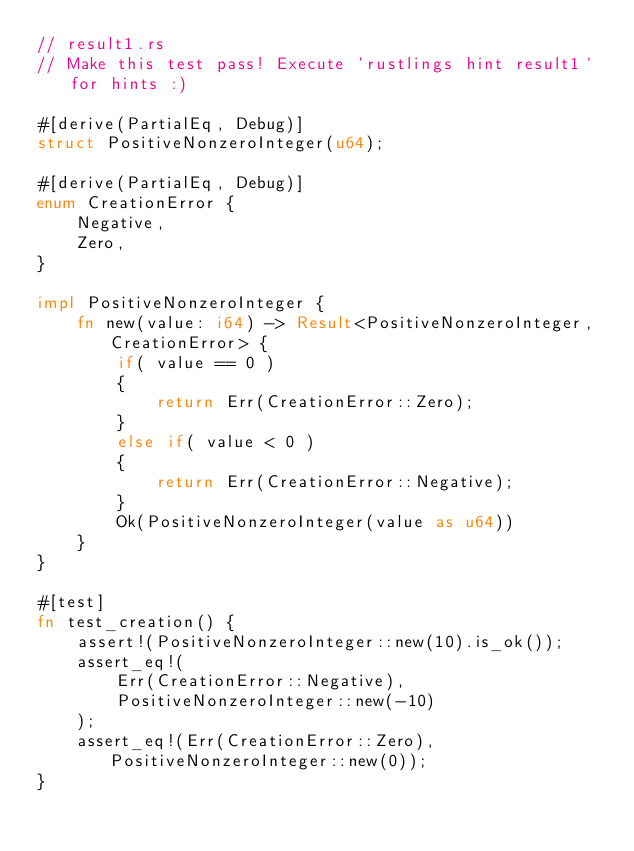Convert code to text. <code><loc_0><loc_0><loc_500><loc_500><_Rust_>// result1.rs
// Make this test pass! Execute `rustlings hint result1` for hints :)

#[derive(PartialEq, Debug)]
struct PositiveNonzeroInteger(u64);

#[derive(PartialEq, Debug)]
enum CreationError {
    Negative,
    Zero,
}

impl PositiveNonzeroInteger {
    fn new(value: i64) -> Result<PositiveNonzeroInteger, CreationError> {
        if( value == 0 )
        {
            return Err(CreationError::Zero);
        }
        else if( value < 0 )
        {
            return Err(CreationError::Negative);
        }
        Ok(PositiveNonzeroInteger(value as u64))
    }
}

#[test]
fn test_creation() {
    assert!(PositiveNonzeroInteger::new(10).is_ok());
    assert_eq!(
        Err(CreationError::Negative),
        PositiveNonzeroInteger::new(-10)
    );
    assert_eq!(Err(CreationError::Zero), PositiveNonzeroInteger::new(0));
}
</code> 